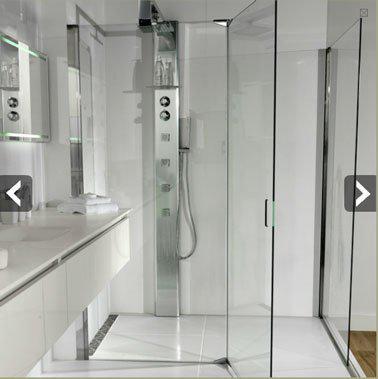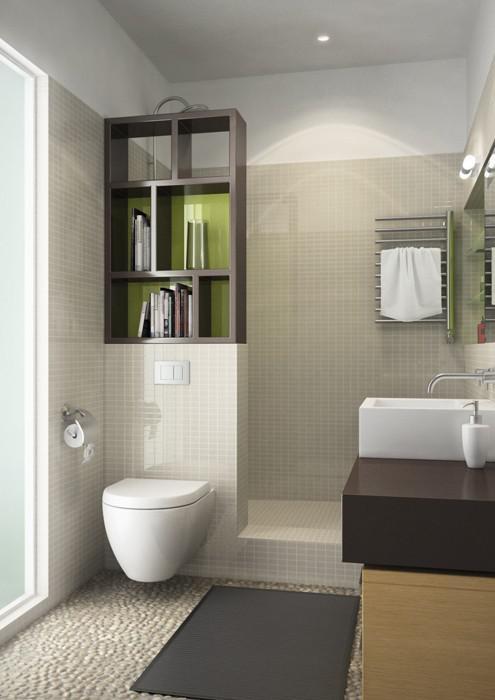The first image is the image on the left, the second image is the image on the right. For the images shown, is this caption "A shower stall with dark subway tile is featured in both images." true? Answer yes or no. No. The first image is the image on the left, the second image is the image on the right. Examine the images to the left and right. Is the description "One bathroom has a squarish mirror above a rectangular white sink and dark tile arranged like brick in the shower area." accurate? Answer yes or no. No. 